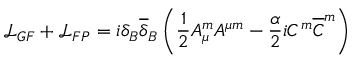<formula> <loc_0><loc_0><loc_500><loc_500>{ \mathcal { L } } _ { G F } + { \mathcal { L } } _ { F P } = i \delta _ { B } { \overline { \delta } } _ { B } \left ( \frac { 1 } { 2 } A _ { \mu } ^ { m } A ^ { \mu m } - \frac { \alpha } { 2 } i C ^ { m } { \overline { C } } ^ { m } \right )</formula> 